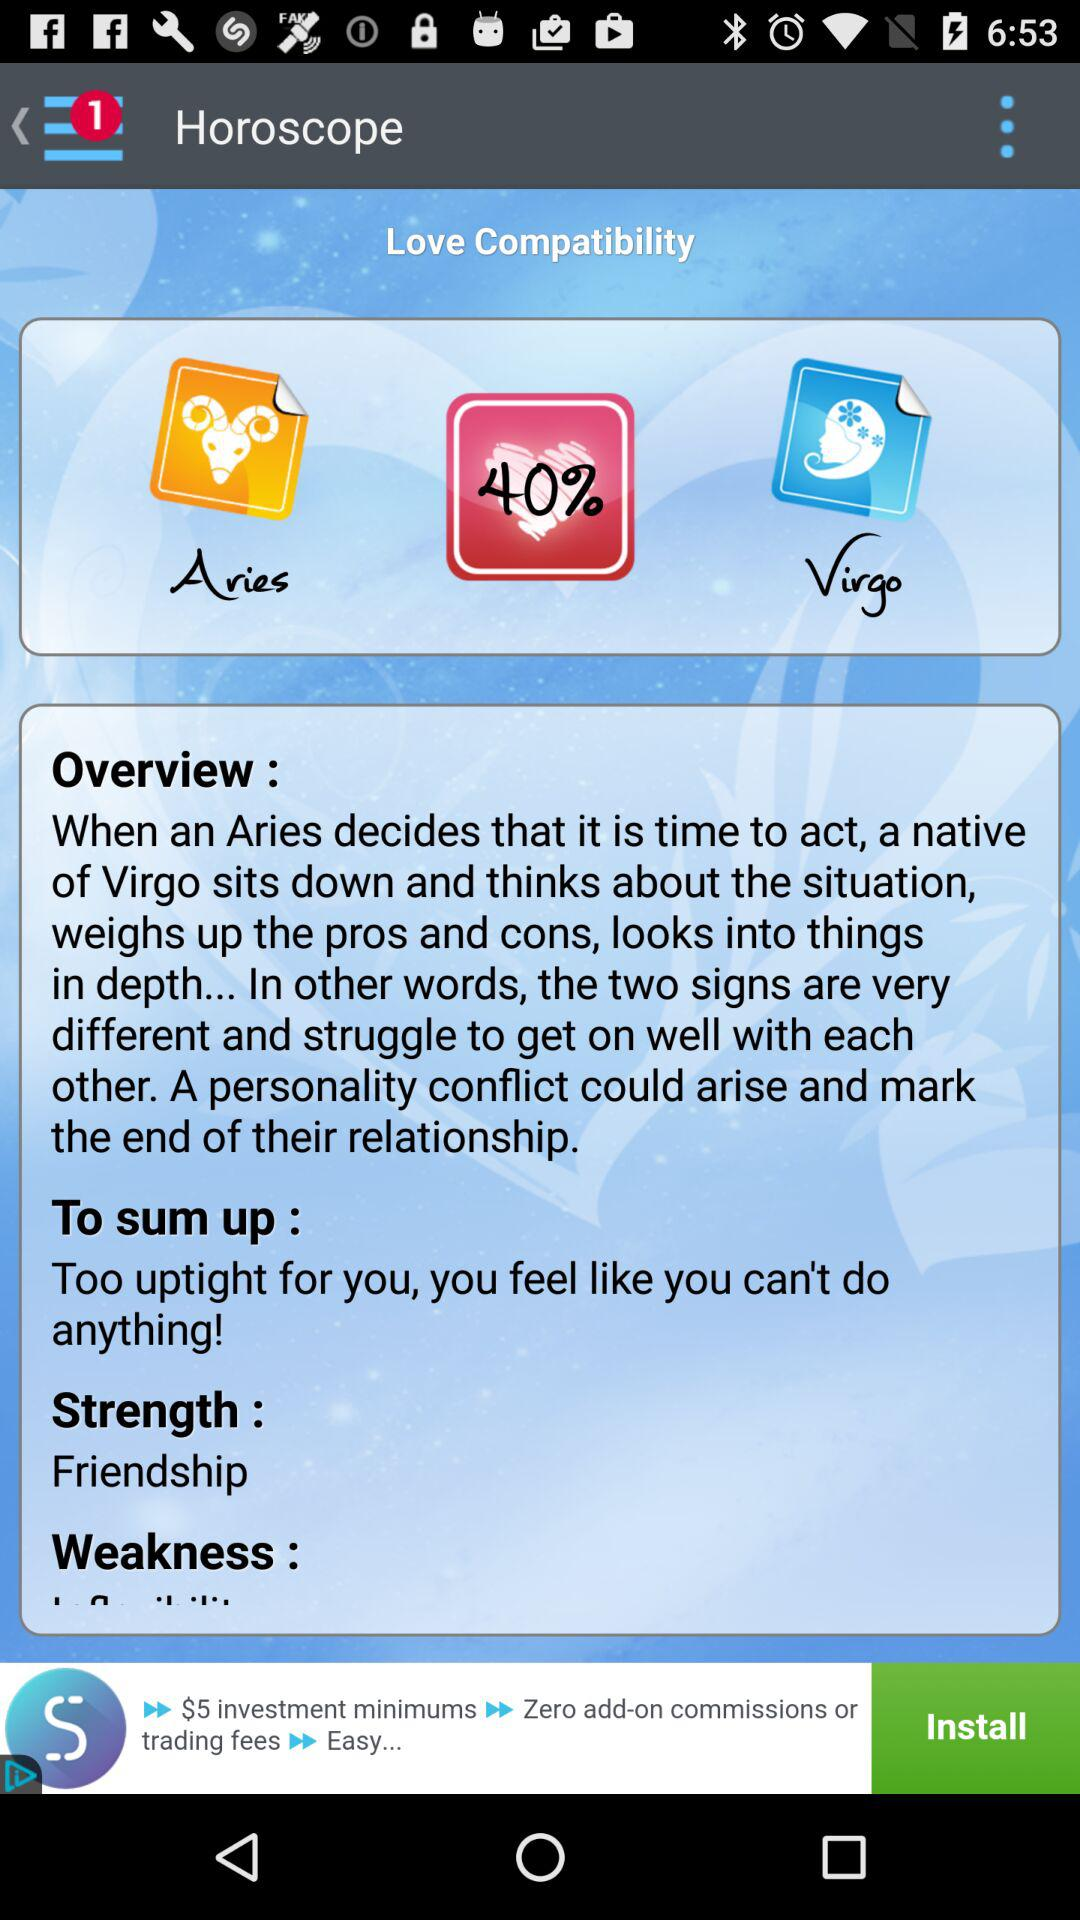What is the percentage of compatibility between Aries and Virgo?
Answer the question using a single word or phrase. 40% 